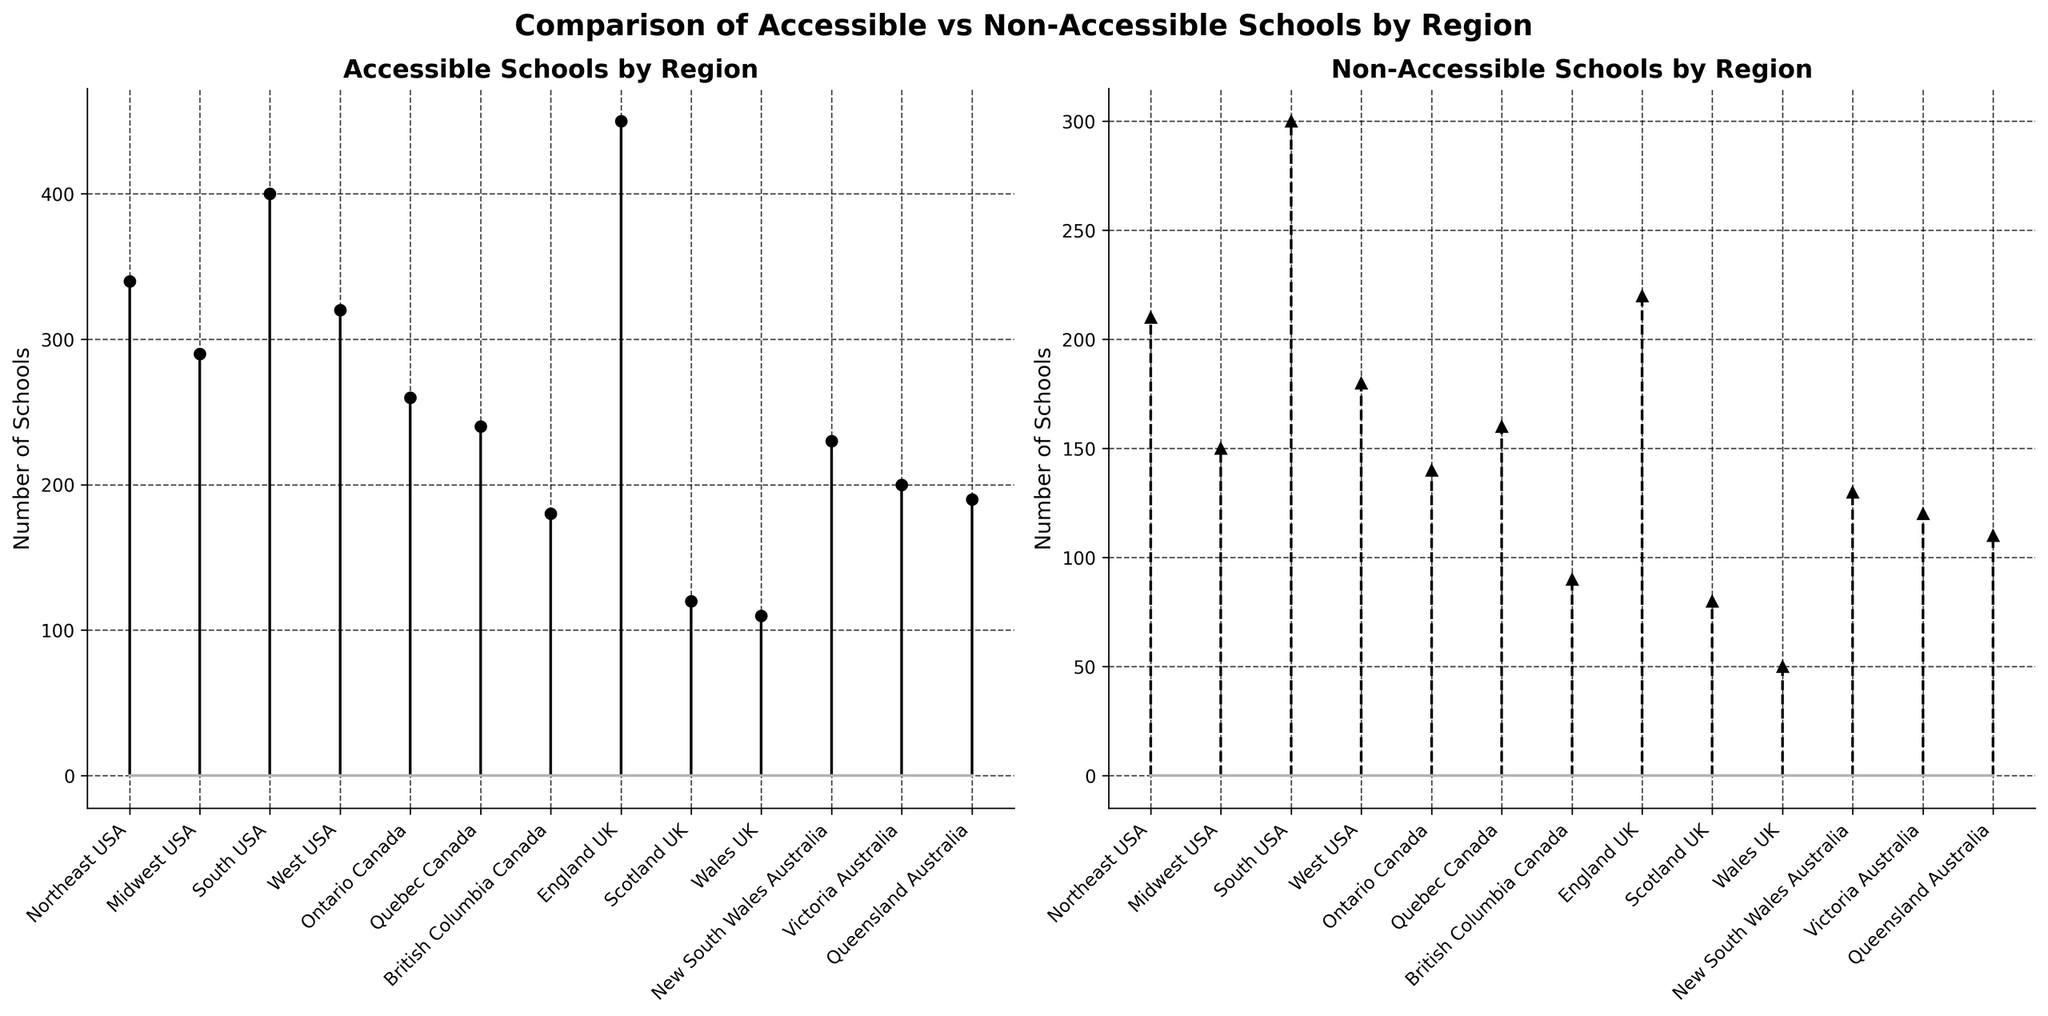what is the title of the figure? The title is usually placed at the top of the figure and summarizes the main topic. It helps viewers quickly understand the context of the data presented.
Answer: Comparison of Accessible vs Non-Accessible Schools by Region Which region has the highest number of accessible schools? By observing the stem plot on the left, identify the highest point, which corresponds to the region with the most accessible schools.
Answer: England UK How many non-accessible schools are there in the Midwest USA? Look at the stem plot on the right, find the Midwest USA region on the x-axis, and see the value marked for non-accessible schools.
Answer: 150 What is the difference between the number of accessible and non-accessible schools in Queensland Australia? Subtract the number of non-accessible schools from accessible schools for Queensland Australia: 190 - 110.
Answer: 80 Which region in the UK has the fewest non-accessible schools? Compare the points for Scotland, Wales, and England UK in the right stem plot, and find the lowest value.
Answer: Wales UK What is the total number of accessible schools in all Australian regions? Sum up the accessible schools for New South Wales (230), Victoria (200), and Queensland (190): 230 + 200 + 190.
Answer: 620 Does Ontario Canada have more accessible or non-accessible schools? Compare the values for accessible (260) and non-accessible (140) in Ontario Canada from the appropriate stem plot.
Answer: More accessible schools Which region has the smallest difference between accessible and non-accessible schools? Calculate the difference for each region and identify the smallest one. For instance,
- Northeast USA: 340 - 210 = 130
- Midwest USA: 290 - 150 = 140
- South USA: 400 - 300 = 100
- West USA: 320 - 180 = 140
- Ontario Canada: 260 - 140 = 120
- Quebec Canada: 240 - 160 = 80
- British Columbia Canada: 180 - 90 = 90
- England UK: 450 - 220 = 230
- Scotland UK: 120 - 80 = 40
- Wales UK: 110 - 50 = 60
- New South Wales Australia: 230 - 130 = 100
- Victoria Australia: 200 - 120 = 80
- Queensland Australia: 190 - 110 = 80
Answer: Quebec Canada 